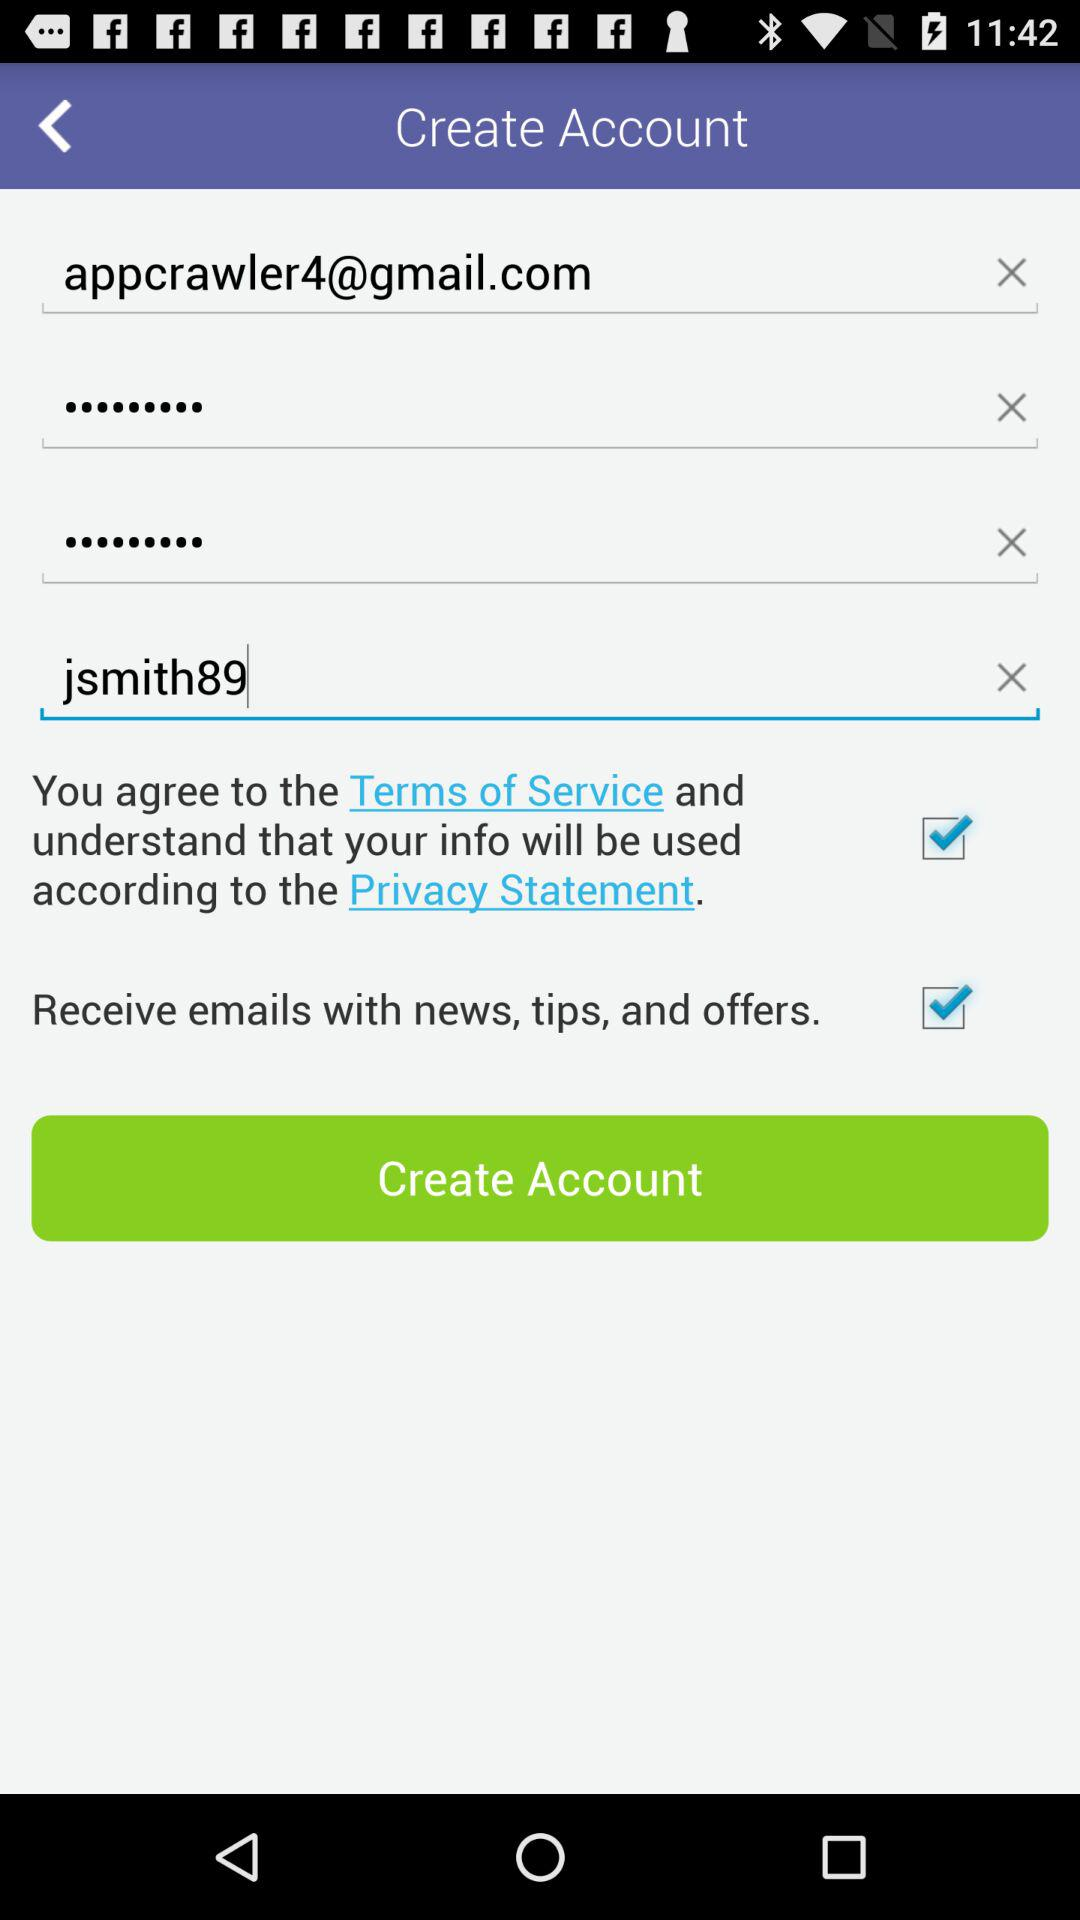How often will "jsmith89" receive emails with news, tips, and offers?
When the provided information is insufficient, respond with <no answer>. <no answer> 